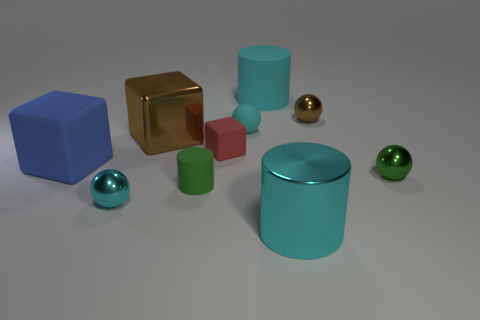Subtract all cylinders. How many objects are left? 7 Subtract all cyan metallic spheres. Subtract all blue rubber things. How many objects are left? 8 Add 5 red things. How many red things are left? 6 Add 2 large yellow rubber cylinders. How many large yellow rubber cylinders exist? 2 Subtract 0 red cylinders. How many objects are left? 10 